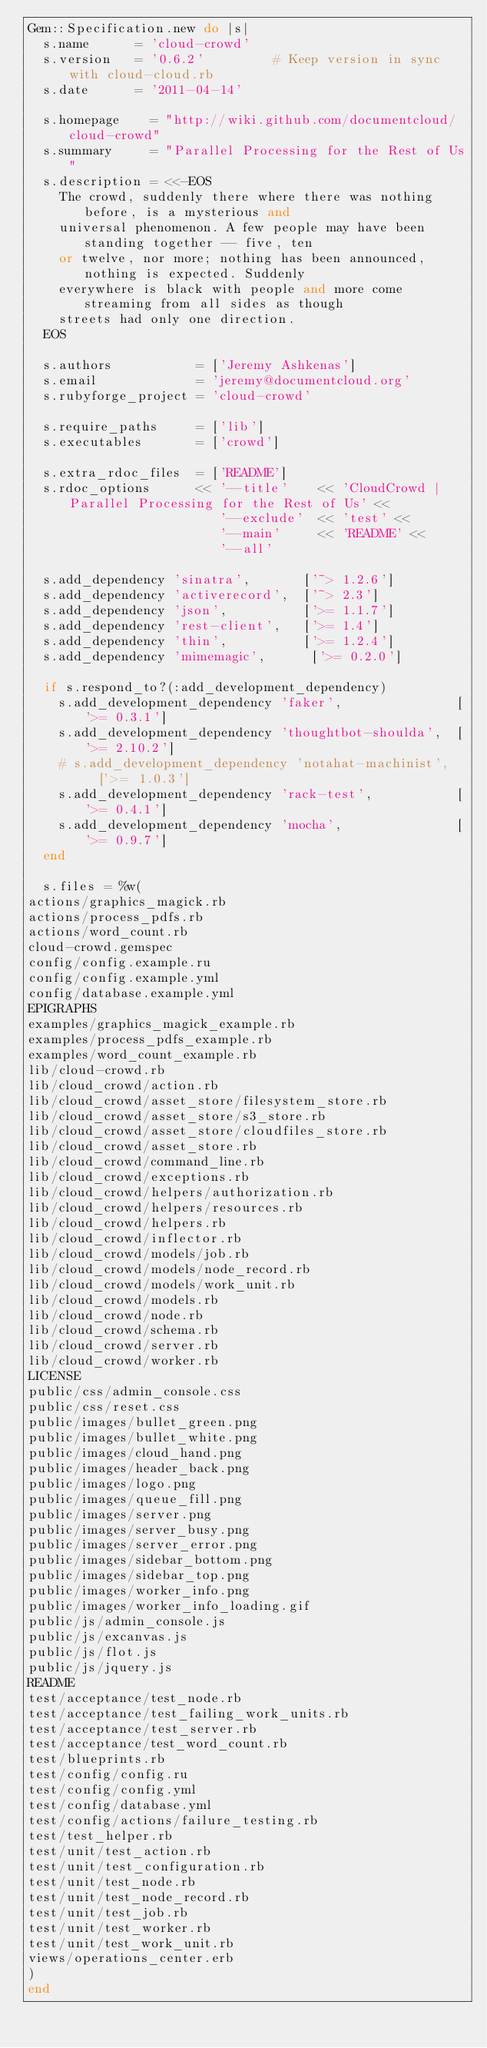Convert code to text. <code><loc_0><loc_0><loc_500><loc_500><_Ruby_>Gem::Specification.new do |s|
  s.name      = 'cloud-crowd'
  s.version   = '0.6.2'         # Keep version in sync with cloud-cloud.rb
  s.date      = '2011-04-14'

  s.homepage    = "http://wiki.github.com/documentcloud/cloud-crowd"
  s.summary     = "Parallel Processing for the Rest of Us"
  s.description = <<-EOS
    The crowd, suddenly there where there was nothing before, is a mysterious and
    universal phenomenon. A few people may have been standing together -- five, ten
    or twelve, nor more; nothing has been announced, nothing is expected. Suddenly
    everywhere is black with people and more come streaming from all sides as though
    streets had only one direction.
  EOS

  s.authors           = ['Jeremy Ashkenas']
  s.email             = 'jeremy@documentcloud.org'
  s.rubyforge_project = 'cloud-crowd'

  s.require_paths     = ['lib']
  s.executables       = ['crowd']

  s.extra_rdoc_files  = ['README']
  s.rdoc_options      << '--title'    << 'CloudCrowd | Parallel Processing for the Rest of Us' <<
                         '--exclude'  << 'test' <<
                         '--main'     << 'README' <<
                         '--all'

  s.add_dependency 'sinatra',       ['~> 1.2.6']
  s.add_dependency 'activerecord',  ['~> 2.3']
  s.add_dependency 'json',          ['>= 1.1.7']
  s.add_dependency 'rest-client',   ['>= 1.4']
  s.add_dependency 'thin',          ['>= 1.2.4']
  s.add_dependency 'mimemagic',      ['>= 0.2.0']

  if s.respond_to?(:add_development_dependency)
    s.add_development_dependency 'faker',               ['>= 0.3.1']
    s.add_development_dependency 'thoughtbot-shoulda',  ['>= 2.10.2']
    # s.add_development_dependency 'notahat-machinist',   ['>= 1.0.3']
    s.add_development_dependency 'rack-test',           ['>= 0.4.1']
    s.add_development_dependency 'mocha',               ['>= 0.9.7']
  end

  s.files = %w(
actions/graphics_magick.rb
actions/process_pdfs.rb
actions/word_count.rb
cloud-crowd.gemspec
config/config.example.ru
config/config.example.yml
config/database.example.yml
EPIGRAPHS
examples/graphics_magick_example.rb
examples/process_pdfs_example.rb
examples/word_count_example.rb
lib/cloud-crowd.rb
lib/cloud_crowd/action.rb
lib/cloud_crowd/asset_store/filesystem_store.rb
lib/cloud_crowd/asset_store/s3_store.rb
lib/cloud_crowd/asset_store/cloudfiles_store.rb
lib/cloud_crowd/asset_store.rb
lib/cloud_crowd/command_line.rb
lib/cloud_crowd/exceptions.rb
lib/cloud_crowd/helpers/authorization.rb
lib/cloud_crowd/helpers/resources.rb
lib/cloud_crowd/helpers.rb
lib/cloud_crowd/inflector.rb
lib/cloud_crowd/models/job.rb
lib/cloud_crowd/models/node_record.rb
lib/cloud_crowd/models/work_unit.rb
lib/cloud_crowd/models.rb
lib/cloud_crowd/node.rb
lib/cloud_crowd/schema.rb
lib/cloud_crowd/server.rb
lib/cloud_crowd/worker.rb
LICENSE
public/css/admin_console.css
public/css/reset.css
public/images/bullet_green.png
public/images/bullet_white.png
public/images/cloud_hand.png
public/images/header_back.png
public/images/logo.png
public/images/queue_fill.png
public/images/server.png
public/images/server_busy.png
public/images/server_error.png
public/images/sidebar_bottom.png
public/images/sidebar_top.png
public/images/worker_info.png
public/images/worker_info_loading.gif
public/js/admin_console.js
public/js/excanvas.js
public/js/flot.js
public/js/jquery.js
README
test/acceptance/test_node.rb
test/acceptance/test_failing_work_units.rb
test/acceptance/test_server.rb
test/acceptance/test_word_count.rb
test/blueprints.rb
test/config/config.ru
test/config/config.yml
test/config/database.yml
test/config/actions/failure_testing.rb
test/test_helper.rb
test/unit/test_action.rb
test/unit/test_configuration.rb
test/unit/test_node.rb
test/unit/test_node_record.rb
test/unit/test_job.rb
test/unit/test_worker.rb
test/unit/test_work_unit.rb
views/operations_center.erb
)
end
</code> 